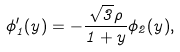<formula> <loc_0><loc_0><loc_500><loc_500>\phi _ { 1 } ^ { \prime } ( y ) = - \frac { \sqrt { 3 } \rho } { 1 + y } \phi _ { 2 } ( y ) ,</formula> 